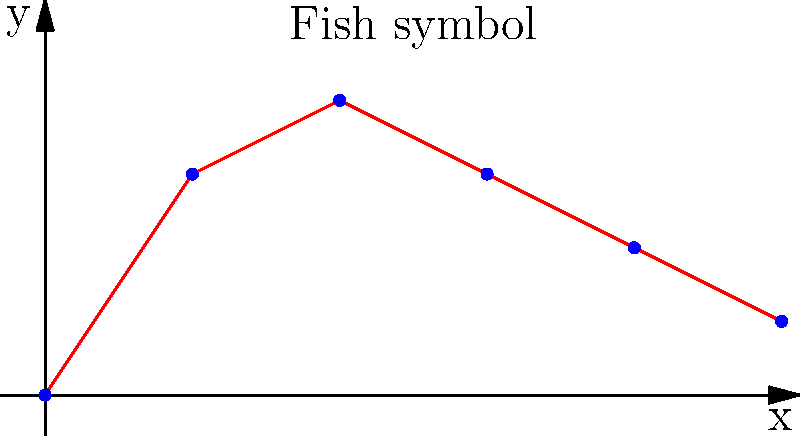You are designing a smooth curve for a fish symbol, an early Christian icon. Given the following data points: (0,0), (1,1.5), (2,2), (3,1.5), (4,1), (5,0.5), what degree polynomial would be most appropriate for interpolation to create a smooth curve that accurately represents the fish symbol? To determine the most appropriate degree for polynomial interpolation, we need to consider the following steps:

1. Count the number of data points: We have 6 points.

2. Recall that for $n$ points, we can use a polynomial of degree at most $n-1$ for exact interpolation.

3. In this case, the maximum degree would be $6-1 = 5$.

4. However, using the maximum degree often leads to overfitting and unnatural oscillations, especially for smooth curves like the fish symbol.

5. We should consider the shape of the curve:
   - It starts at (0,0)
   - Rises to a peak at (2,2)
   - Then gradually descends

6. This shape suggests a parabola-like curve, which can be well-approximated by a quadratic (degree 2) or cubic (degree 3) polynomial.

7. A cubic polynomial (degree 3) would provide more flexibility to capture the slight asymmetry of the fish symbol while still maintaining a smooth curve.

8. Using a degree 3 polynomial also allows for some error tolerance, which is beneficial when working with hand-drawn or approximated data points for religious symbols.

Therefore, a cubic polynomial (degree 3) would be most appropriate for interpolating this fish symbol curve, balancing accuracy and smoothness.
Answer: Degree 3 (cubic) polynomial 